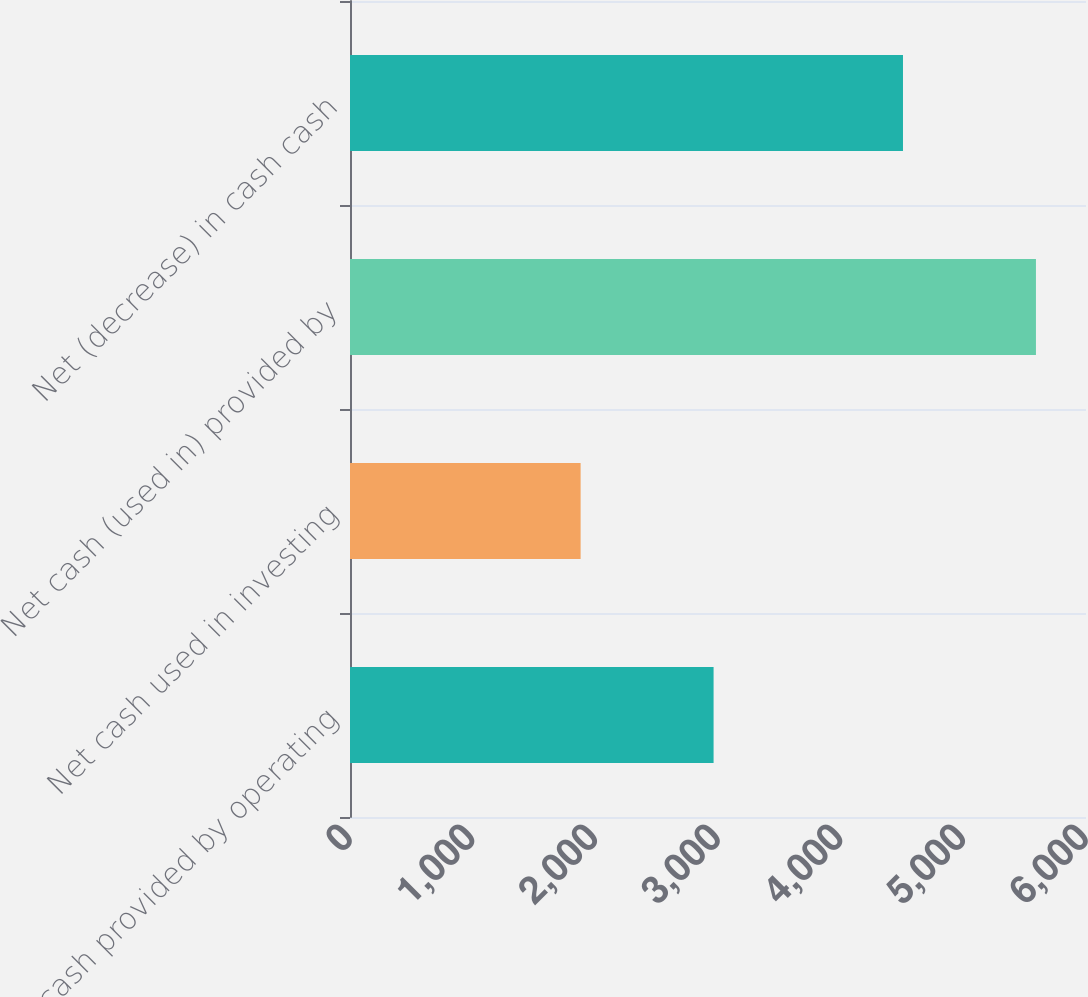<chart> <loc_0><loc_0><loc_500><loc_500><bar_chart><fcel>Net cash provided by operating<fcel>Net cash used in investing<fcel>Net cash (used in) provided by<fcel>Net (decrease) in cash cash<nl><fcel>2964<fcel>1880<fcel>5592<fcel>4508<nl></chart> 